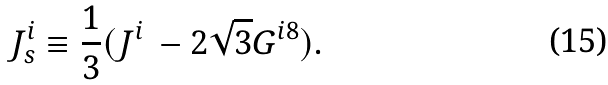Convert formula to latex. <formula><loc_0><loc_0><loc_500><loc_500>J _ { s } ^ { i } \equiv \frac { 1 } { 3 } ( J ^ { i } \, - 2 \sqrt { 3 } G ^ { i 8 } ) .</formula> 